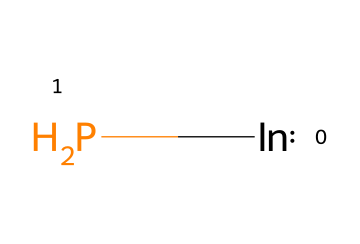What elements are present in this compound? The SMILES representation [In]P indicates the presence of indium (In) and phosphorus (P).
Answer: indium, phosphorus How many atoms are in the chemical structure? There are two types of atoms (indium and phosphorus), but if counting individual atoms, there are a total of two atoms.
Answer: 2 What is the chemical formula for this compound? From the SMILES representation, the compound is composed of one indium atom and one phosphorus atom, giving the formula InP.
Answer: InP What type of semiconductor is indium phosphide classified as? Indium phosphide is known as a direct bandgap semiconductor, suitable for optoelectronic applications including solar panels.
Answer: direct bandgap Why is indium phosphide used in solar panels for outdoor music festivals? Indium phosphide's unique properties, such as high electron mobility and efficiency in light absorption, make it ideal for converting sunlight into electricity, enhancing solar panel performance.
Answer: efficiency How does the composition of indium phosphide affect its quantum dot formation? The composition of indium and phosphorus contributes to the size and electronic properties of quantum dots, which influence their light emission characteristics and efficiency in solar applications.
Answer: electronic properties What advantage do quantum dots made from indium phosphide provide? Quantum dots from indium phosphide allow for tunable light absorption and emission, providing better efficiency in converting solar energy to electricity in panels.
Answer: tunable properties 